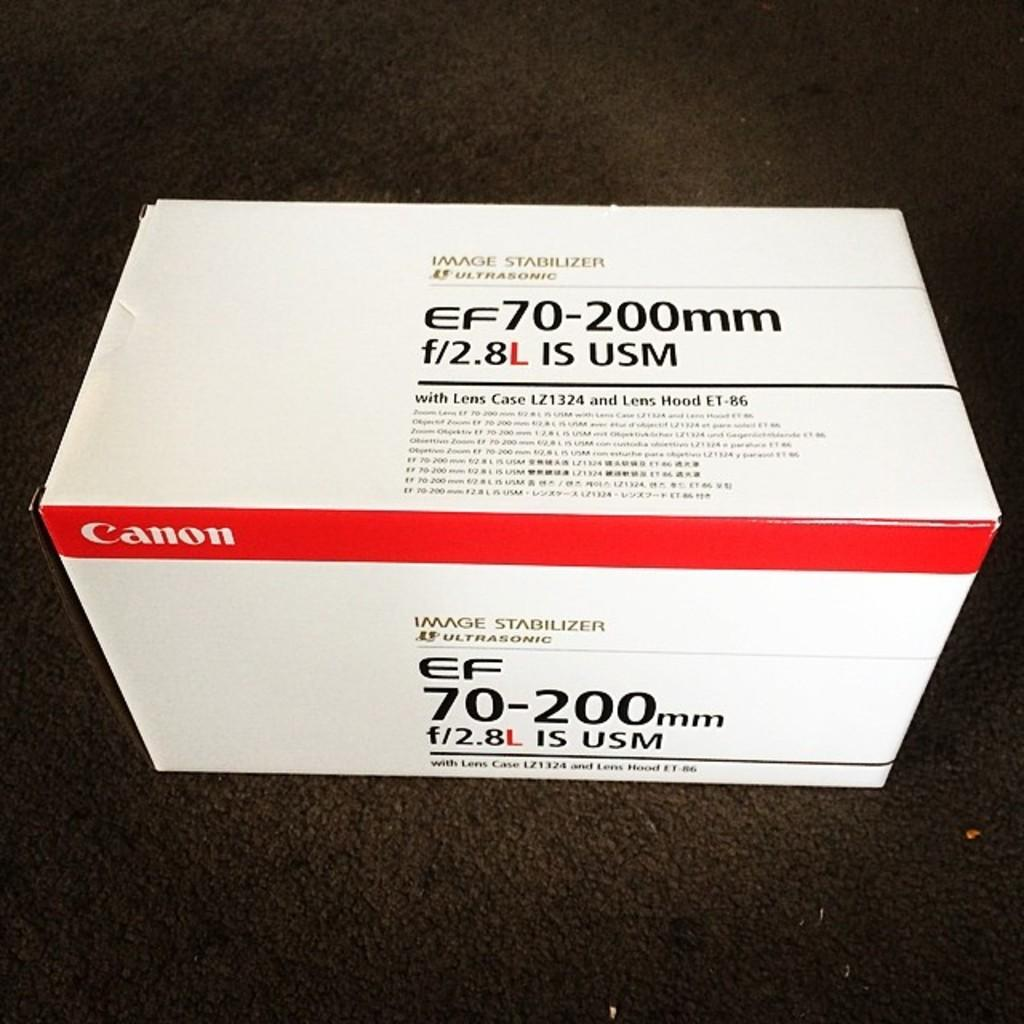Provide a one-sentence caption for the provided image. Canon camera lens in the box and comes with a case according to the writing on the box. 